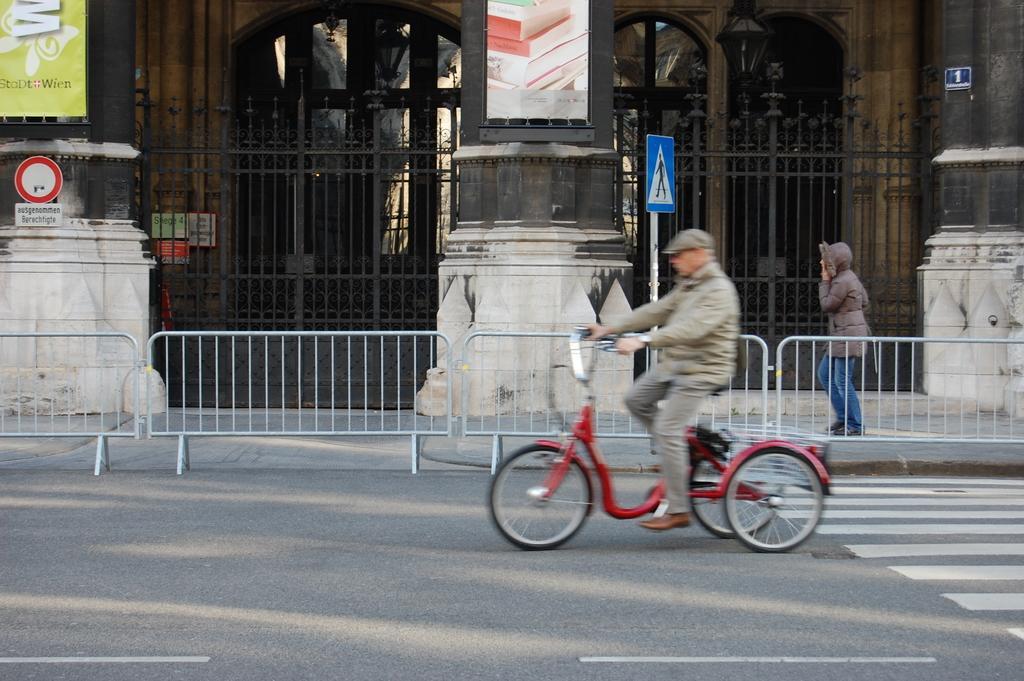Can you describe this image briefly? A guy is riding a bicycle and in the background we find a huge building with glass windows and there is a pedestrian walk way on which a lady is walking. There are few sign boards attached on the poles. 